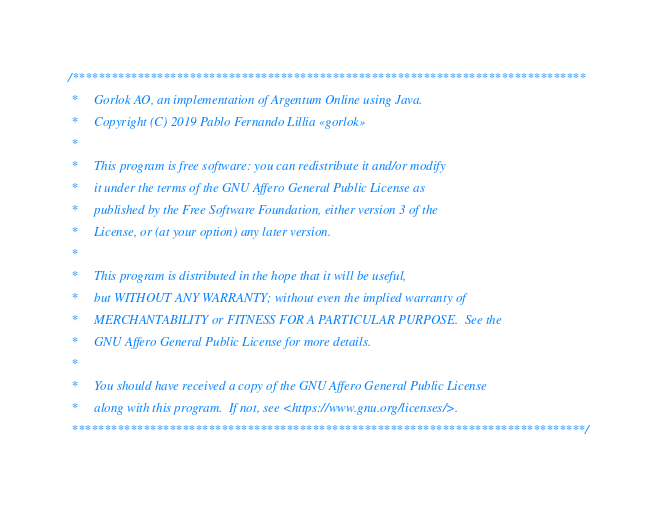Convert code to text. <code><loc_0><loc_0><loc_500><loc_500><_Java_>/*******************************************************************************
 *     Gorlok AO, an implementation of Argentum Online using Java.
 *     Copyright (C) 2019 Pablo Fernando Lillia «gorlok» 
 *
 *     This program is free software: you can redistribute it and/or modify
 *     it under the terms of the GNU Affero General Public License as
 *     published by the Free Software Foundation, either version 3 of the
 *     License, or (at your option) any later version.
 *
 *     This program is distributed in the hope that it will be useful,
 *     but WITHOUT ANY WARRANTY; without even the implied warranty of
 *     MERCHANTABILITY or FITNESS FOR A PARTICULAR PURPOSE.  See the
 *     GNU Affero General Public License for more details.
 *
 *     You should have received a copy of the GNU Affero General Public License
 *     along with this program.  If not, see <https://www.gnu.org/licenses/>.
 *******************************************************************************/</code> 